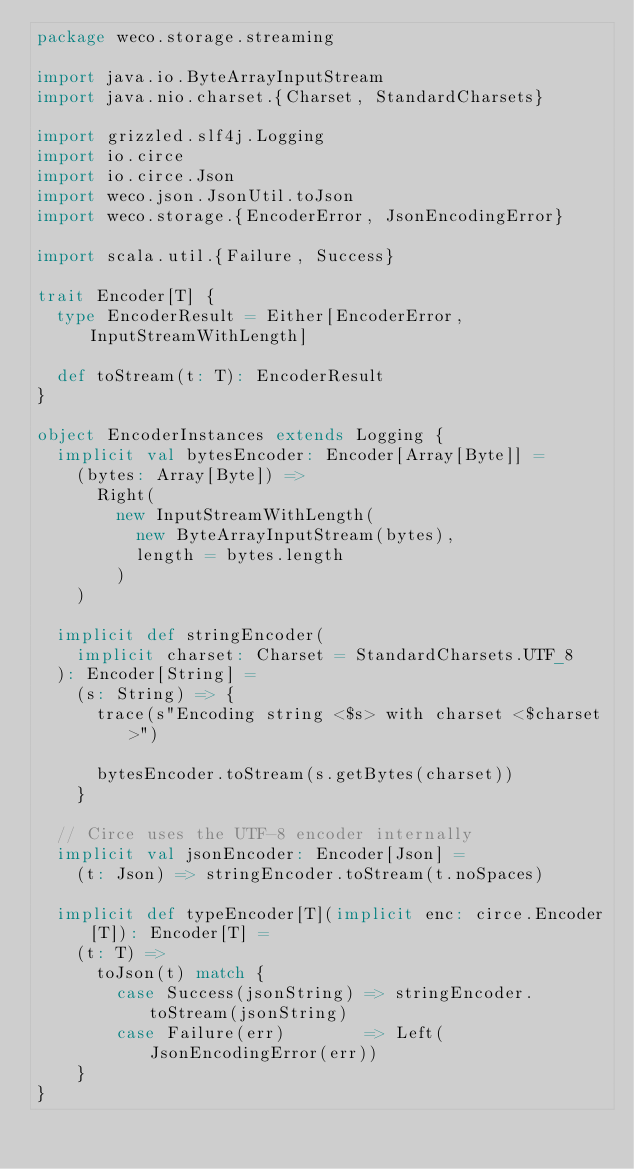<code> <loc_0><loc_0><loc_500><loc_500><_Scala_>package weco.storage.streaming

import java.io.ByteArrayInputStream
import java.nio.charset.{Charset, StandardCharsets}

import grizzled.slf4j.Logging
import io.circe
import io.circe.Json
import weco.json.JsonUtil.toJson
import weco.storage.{EncoderError, JsonEncodingError}

import scala.util.{Failure, Success}

trait Encoder[T] {
  type EncoderResult = Either[EncoderError, InputStreamWithLength]

  def toStream(t: T): EncoderResult
}

object EncoderInstances extends Logging {
  implicit val bytesEncoder: Encoder[Array[Byte]] =
    (bytes: Array[Byte]) =>
      Right(
        new InputStreamWithLength(
          new ByteArrayInputStream(bytes),
          length = bytes.length
        )
    )

  implicit def stringEncoder(
    implicit charset: Charset = StandardCharsets.UTF_8
  ): Encoder[String] =
    (s: String) => {
      trace(s"Encoding string <$s> with charset <$charset>")

      bytesEncoder.toStream(s.getBytes(charset))
    }

  // Circe uses the UTF-8 encoder internally
  implicit val jsonEncoder: Encoder[Json] =
    (t: Json) => stringEncoder.toStream(t.noSpaces)

  implicit def typeEncoder[T](implicit enc: circe.Encoder[T]): Encoder[T] =
    (t: T) =>
      toJson(t) match {
        case Success(jsonString) => stringEncoder.toStream(jsonString)
        case Failure(err)        => Left(JsonEncodingError(err))
    }
}
</code> 